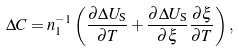<formula> <loc_0><loc_0><loc_500><loc_500>\Delta C = n _ { 1 } ^ { - 1 } \left ( \frac { \partial \Delta U _ { \text {S} } } { \partial T } + \frac { \partial \Delta U _ { \text {S} } } { \partial \xi } \frac { \partial \xi } { \partial T } \right ) ,</formula> 